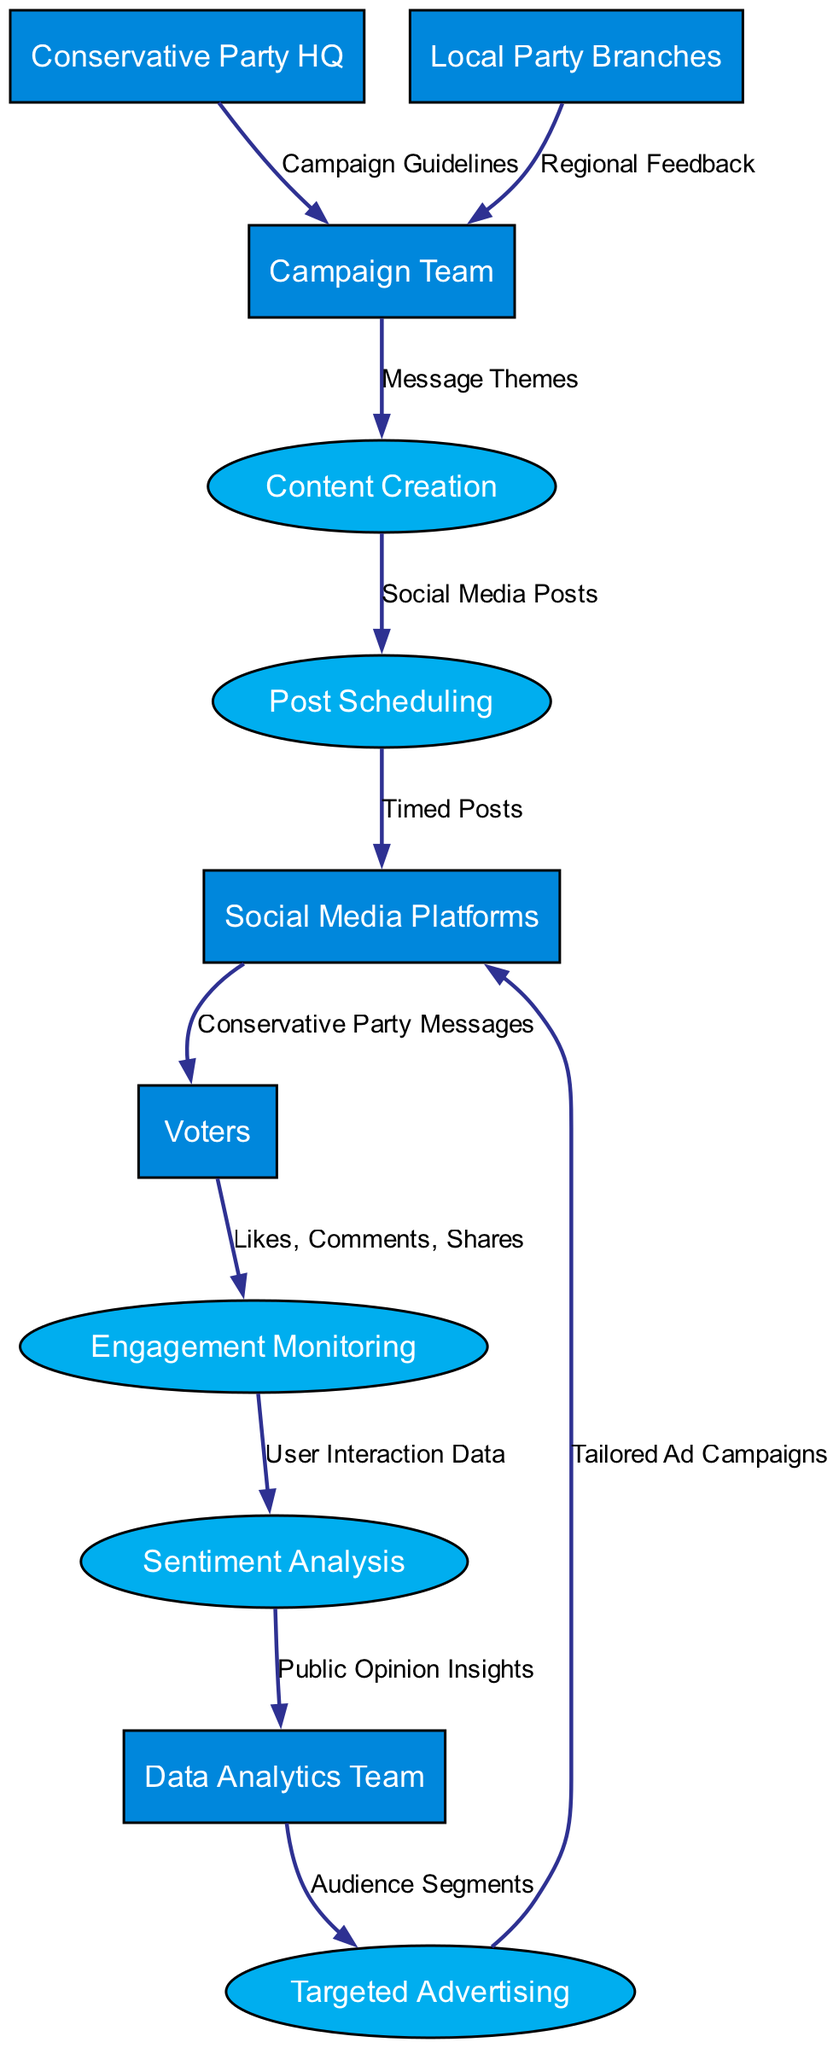What is the total number of entities in the diagram? The diagram lists the entities as follows: Conservative Party HQ, Local Party Branches, Campaign Team, Social Media Platforms, Voters, and Data Analytics Team. Counting them gives a total of six entities.
Answer: 6 Which node represents the process of evaluating public sentiment? The node labeled "Sentiment Analysis" is specifically designated for evaluating public sentiment based on user interaction data collected from engagement activities.
Answer: Sentiment Analysis How many processes are shown in the diagram? The processes listed in the diagram are: Content Creation, Post Scheduling, Engagement Monitoring, Sentiment Analysis, and Targeted Advertising. By counting them, we find there are five processes in total.
Answer: 5 What type of data does the "Engagement Monitoring" node receive? The data received by the Engagement Monitoring node is specified as "Likes, Comments, Shares," which are engagement metrics from voters' interactions with the posts on social media.
Answer: Likes, Comments, Shares What connects "Data Analytics Team" to "Targeted Advertising"? The connection is made through the data flow labeled "Audience Segments," which indicates that the Data Analytics Team provides audience segments to the Targeted Advertising process for refined ad campaigns.
Answer: Audience Segments What is the last process that social media posts go through before reaching voters? Before reaching voters, social media posts go through the "Social Media Platforms" node, which is responsible for delivering the timed posts created by the campaign team.
Answer: Social Media Platforms Which entity provides regional feedback to the Campaign Team? The entity that provides regional feedback is the "Local Party Branches," which contributes insights specific to regional activities and responses.
Answer: Local Party Branches At what step does user interaction data transition to public opinion insights? User Interaction Data that flows from the Engagement Monitoring node is forwarded to the Sentiment Analysis process. This step is crucial as it transforms user engagement data into public opinion insights for the analytics team.
Answer: Sentiment Analysis 